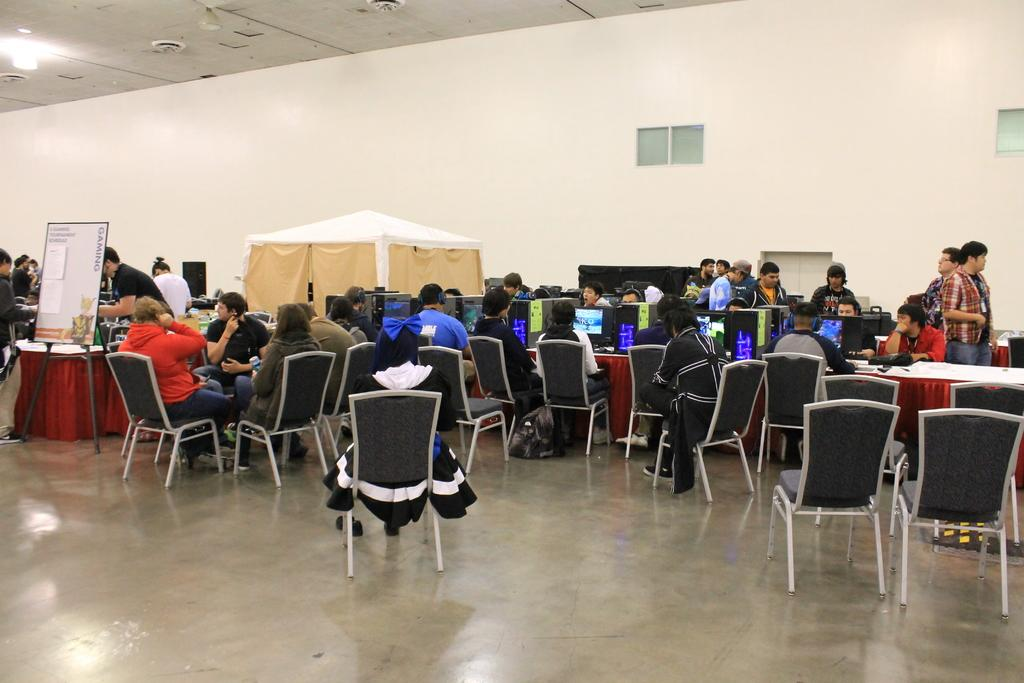What is the color of the wall in the image? The wall in the image is white. What can be seen on the wall in the image? There is a window on the wall in the image. What are the people in the image doing? The people in the image are sitting on chairs. What is hanging on the wall in the image? There is a banner in the image. What type of furniture is present in the image? There are tables in the image. What objects are on the tables in the image? There are laptops and bottles on the tables in the image. What type of stone is present on the tables in the image? There is no stone present on the tables in the image; there are laptops and bottles. How does the connection between the people in the image affect the banner's message? The connection between the people in the image does not affect the banner's message, as the banner is a separate object and not related to the people's interactions. 